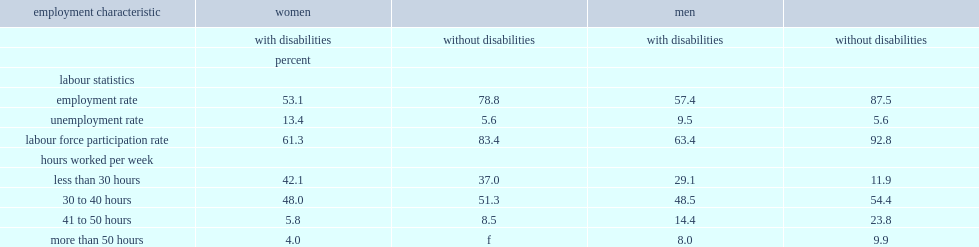What was the proportion of women aged 25 to 54 with disabilities reported working part-time, that is less than 30 hours? 42.1. What was the proportion of women aged 25 to 54 without disabilities reported working part-time, that is less than 30 hours? 37.0. What was the proportion of men aged 25 to 54 with disabilities reported working part-time, that is less than 30 hours? 29.1. What was the proportion of women aged 25 to 54 with disabilities reported working part-time, that is between 41 and 50 hours? 5.8. What was the proportion of men aged 25 to 54 with disabilities reported working part-time, that is between 41 and 50 hours? 14.4. What was the proportion of women aged 25 to 54 without disabilities reported working part-time, that is between 41 and 50 hours? 8.5. What was the proportion of men aged 25 to 54 without disabilities reported working part-time, that is between 41 and 50 hours? 23.8. 